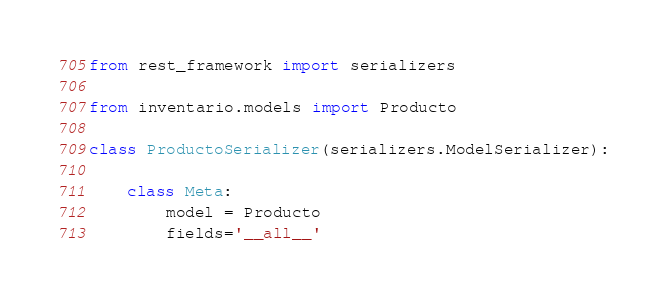Convert code to text. <code><loc_0><loc_0><loc_500><loc_500><_Python_>from rest_framework import serializers

from inventario.models import Producto

class ProductoSerializer(serializers.ModelSerializer):

    class Meta:
        model = Producto
        fields='__all__'</code> 